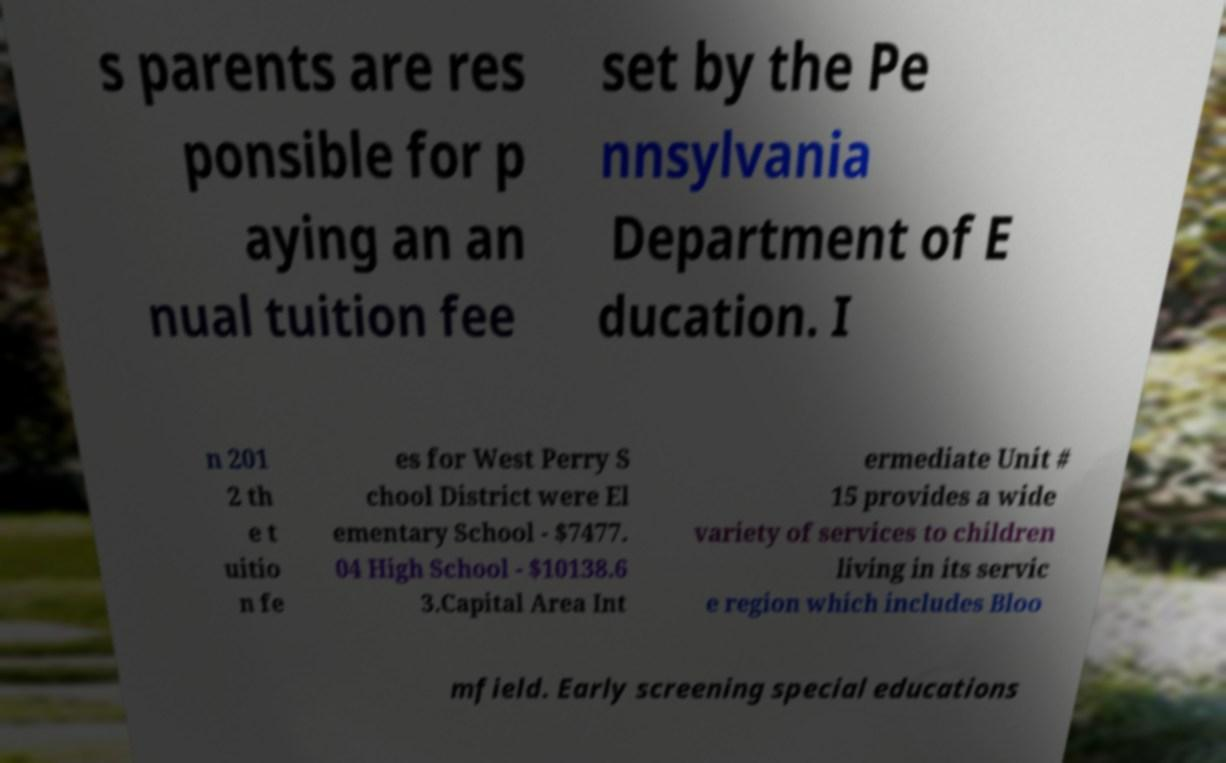Can you accurately transcribe the text from the provided image for me? s parents are res ponsible for p aying an an nual tuition fee set by the Pe nnsylvania Department of E ducation. I n 201 2 th e t uitio n fe es for West Perry S chool District were El ementary School - $7477. 04 High School - $10138.6 3.Capital Area Int ermediate Unit # 15 provides a wide variety of services to children living in its servic e region which includes Bloo mfield. Early screening special educations 